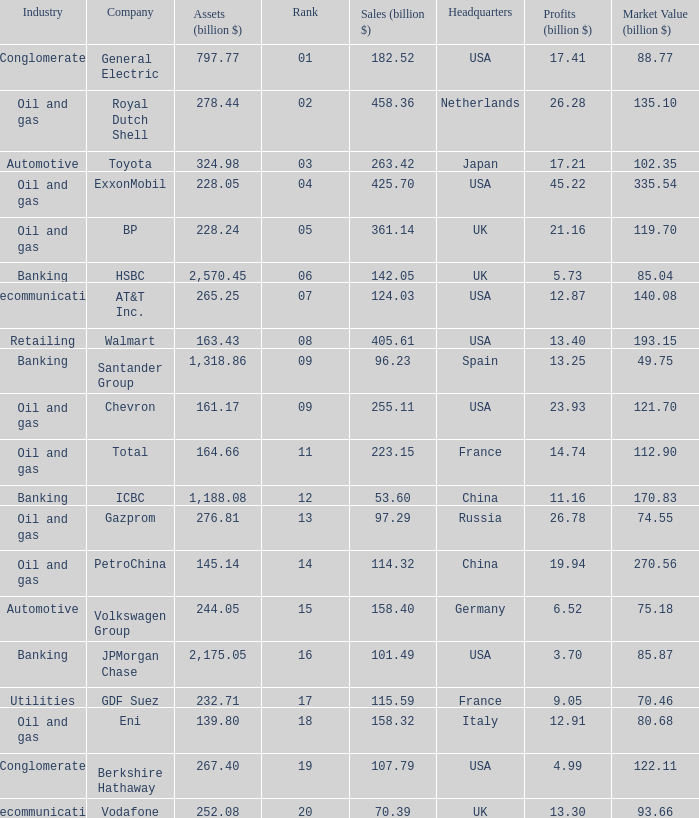How many Assets (billion $) has an Industry of oil and gas, and a Rank of 9, and a Market Value (billion $) larger than 121.7? None. 